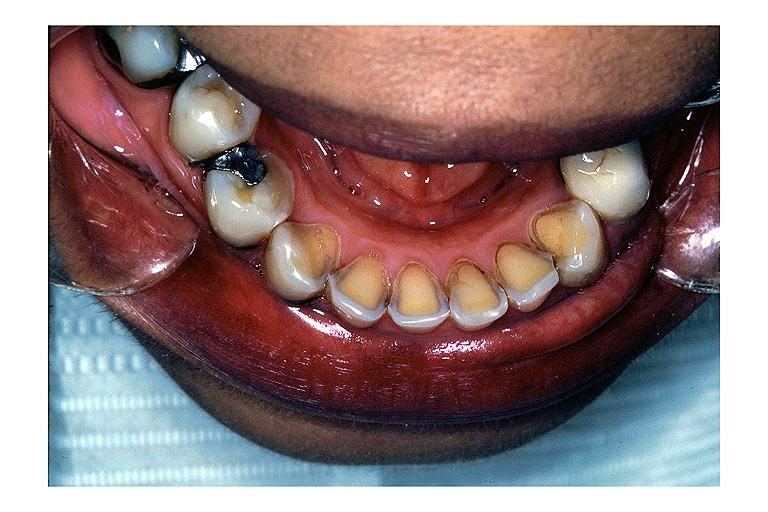what is present?
Answer the question using a single word or phrase. Oral 